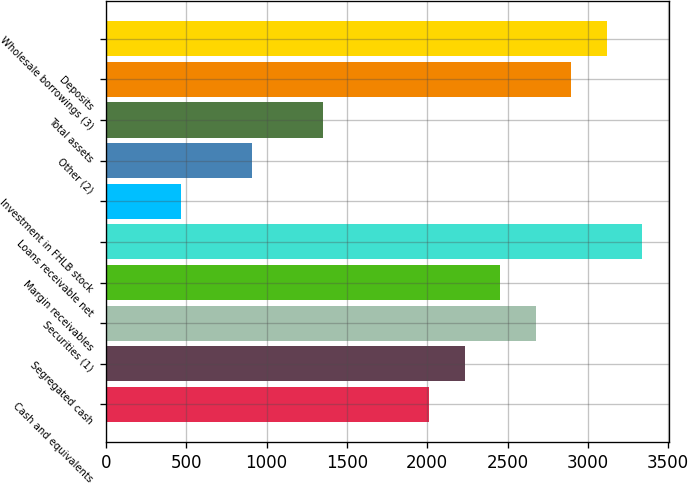Convert chart. <chart><loc_0><loc_0><loc_500><loc_500><bar_chart><fcel>Cash and equivalents<fcel>Segregated cash<fcel>Securities (1)<fcel>Margin receivables<fcel>Loans receivable net<fcel>Investment in FHLB stock<fcel>Other (2)<fcel>Total assets<fcel>Deposits<fcel>Wholesale borrowings (3)<nl><fcel>2013.04<fcel>2234.1<fcel>2676.22<fcel>2455.16<fcel>3339.4<fcel>465.62<fcel>907.74<fcel>1349.86<fcel>2897.28<fcel>3118.34<nl></chart> 